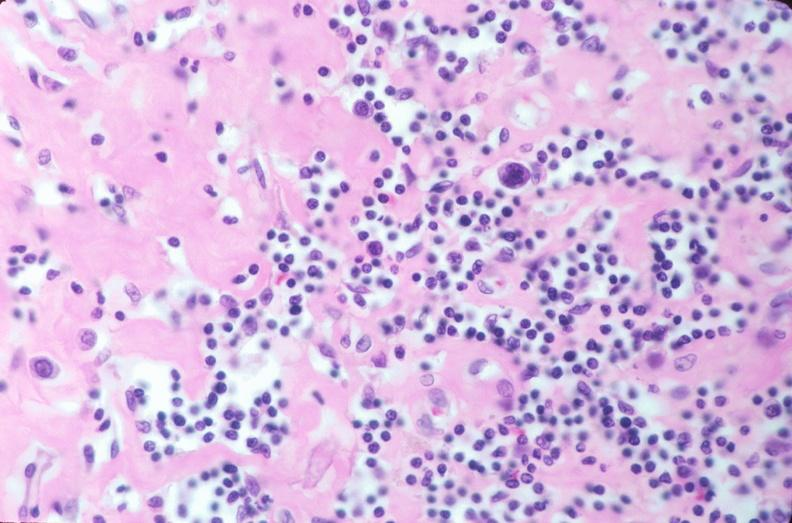does this image show lymph nodes, nodular sclerosing hodgkins disease?
Answer the question using a single word or phrase. Yes 